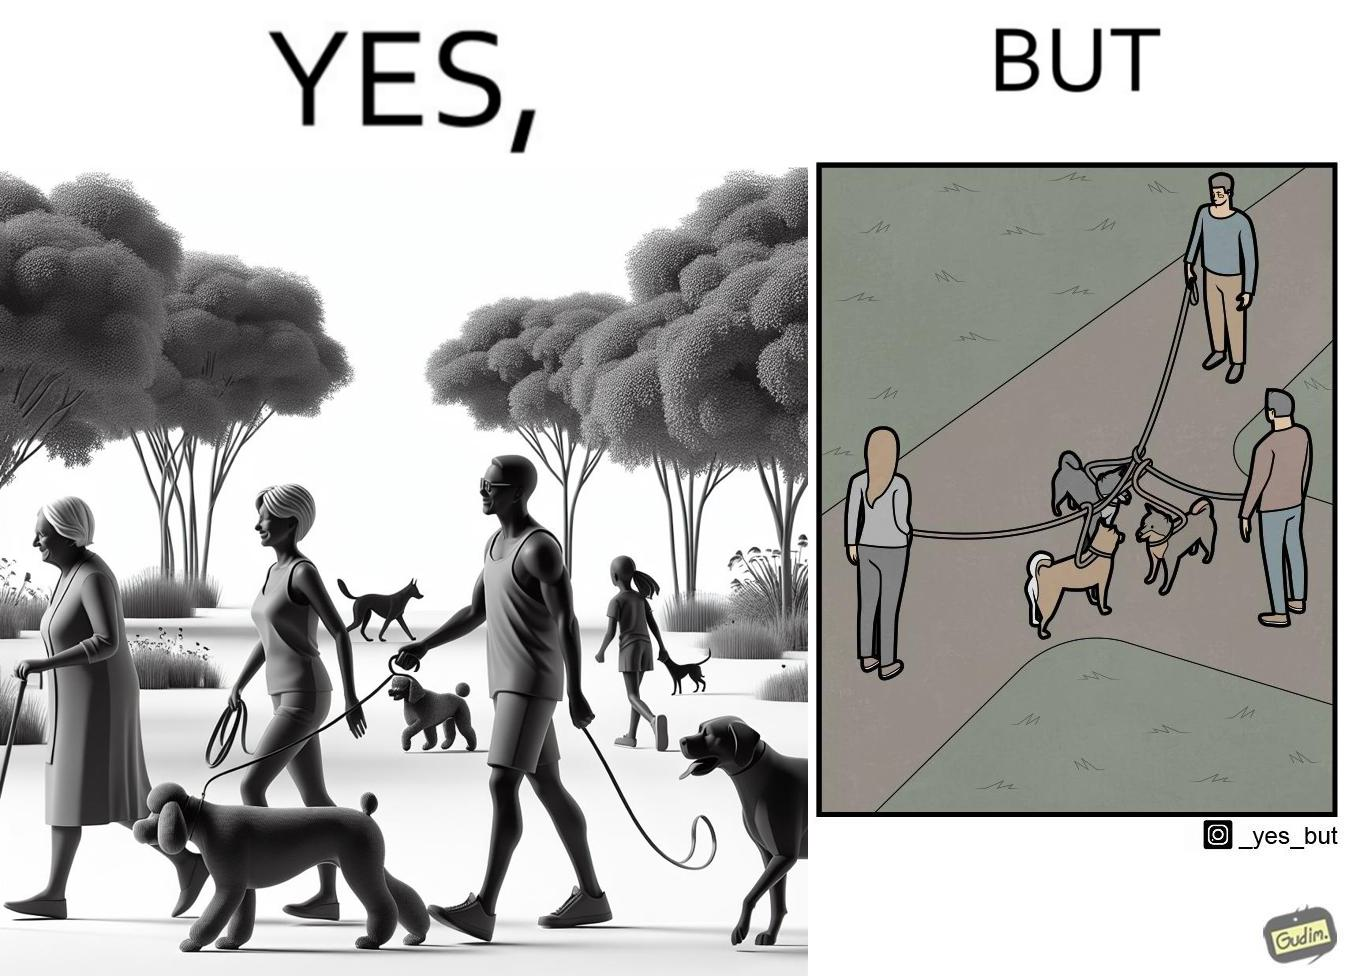What is shown in this image? The dog owners take their dogs for some walk in parks but their dogs mingle together with other dogs however their leashes get entangled during this which is quite inconvenient for the dog owners 